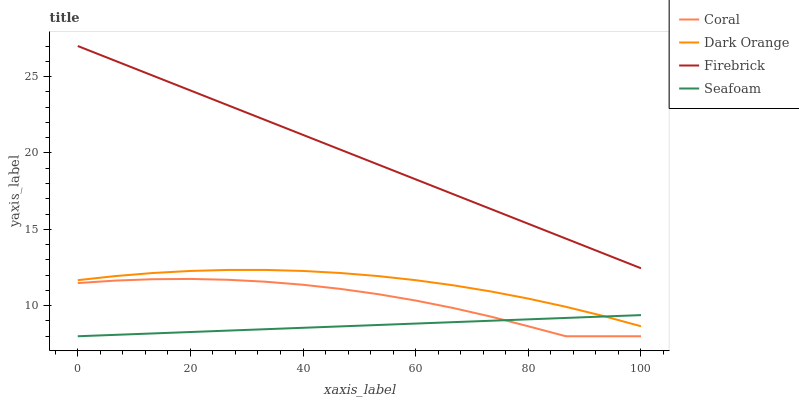Does Seafoam have the minimum area under the curve?
Answer yes or no. Yes. Does Firebrick have the maximum area under the curve?
Answer yes or no. Yes. Does Coral have the minimum area under the curve?
Answer yes or no. No. Does Coral have the maximum area under the curve?
Answer yes or no. No. Is Seafoam the smoothest?
Answer yes or no. Yes. Is Coral the roughest?
Answer yes or no. Yes. Is Firebrick the smoothest?
Answer yes or no. No. Is Firebrick the roughest?
Answer yes or no. No. Does Firebrick have the lowest value?
Answer yes or no. No. Does Coral have the highest value?
Answer yes or no. No. Is Coral less than Dark Orange?
Answer yes or no. Yes. Is Dark Orange greater than Coral?
Answer yes or no. Yes. Does Coral intersect Dark Orange?
Answer yes or no. No. 